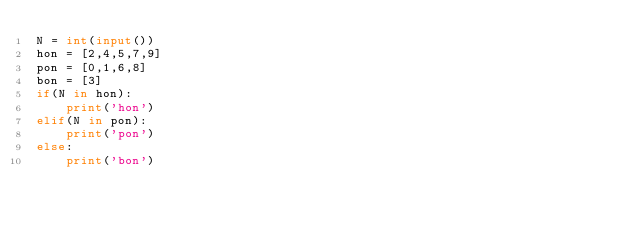<code> <loc_0><loc_0><loc_500><loc_500><_Python_>N = int(input())
hon = [2,4,5,7,9]
pon = [0,1,6,8]
bon = [3]
if(N in hon):
    print('hon')
elif(N in pon):
    print('pon')
else:
    print('bon')</code> 